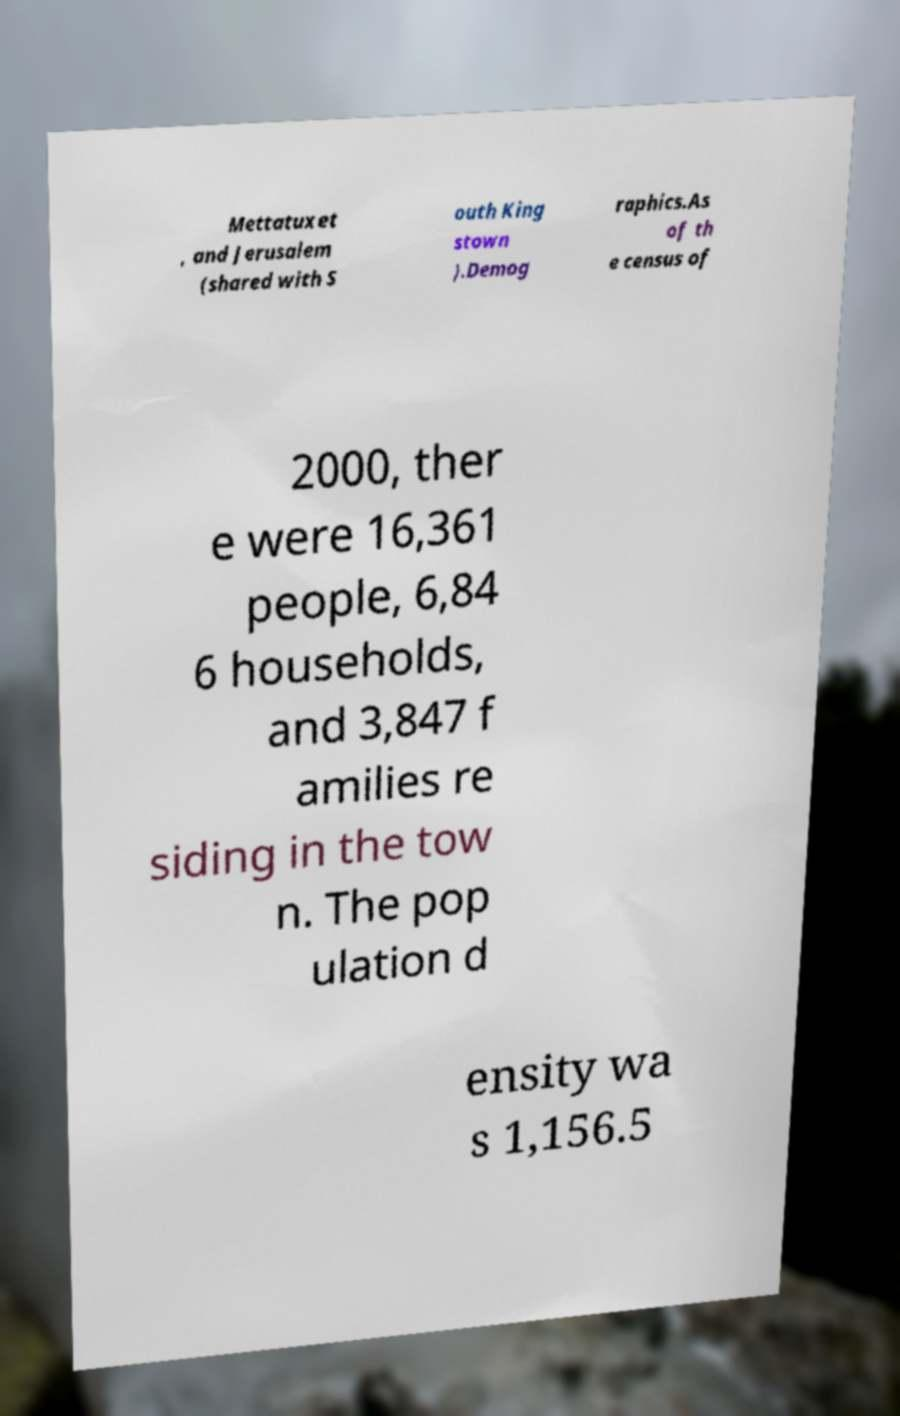There's text embedded in this image that I need extracted. Can you transcribe it verbatim? Mettatuxet , and Jerusalem (shared with S outh King stown ).Demog raphics.As of th e census of 2000, ther e were 16,361 people, 6,84 6 households, and 3,847 f amilies re siding in the tow n. The pop ulation d ensity wa s 1,156.5 